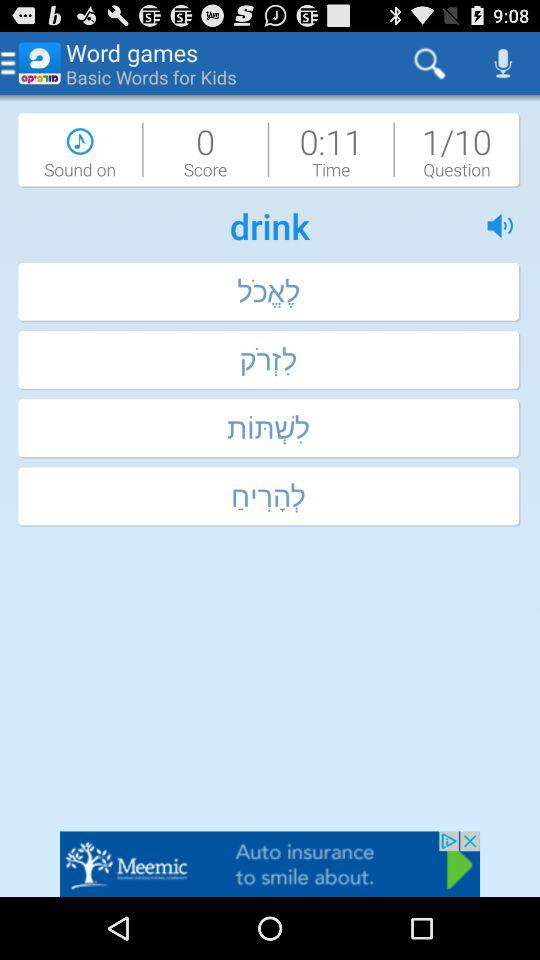What is the application name? The application name is "Morfix - English to Hebrew Tra". 